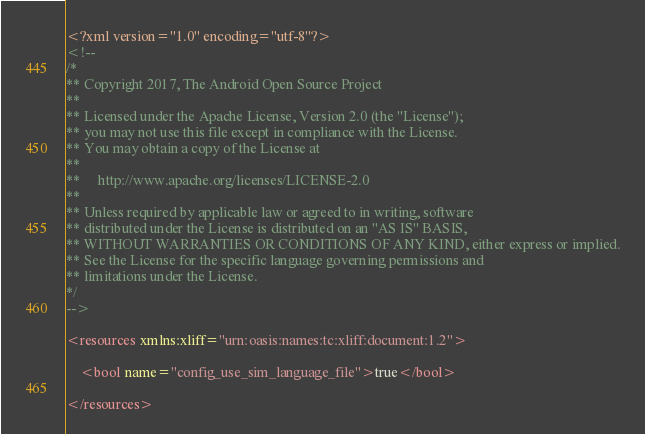Convert code to text. <code><loc_0><loc_0><loc_500><loc_500><_XML_><?xml version="1.0" encoding="utf-8"?>
<!--
/*
** Copyright 2017, The Android Open Source Project
**
** Licensed under the Apache License, Version 2.0 (the "License");
** you may not use this file except in compliance with the License.
** You may obtain a copy of the License at
**
**     http://www.apache.org/licenses/LICENSE-2.0
**
** Unless required by applicable law or agreed to in writing, software
** distributed under the License is distributed on an "AS IS" BASIS,
** WITHOUT WARRANTIES OR CONDITIONS OF ANY KIND, either express or implied.
** See the License for the specific language governing permissions and
** limitations under the License.
*/
-->

<resources xmlns:xliff="urn:oasis:names:tc:xliff:document:1.2">

    <bool name="config_use_sim_language_file">true</bool>

</resources>
</code> 